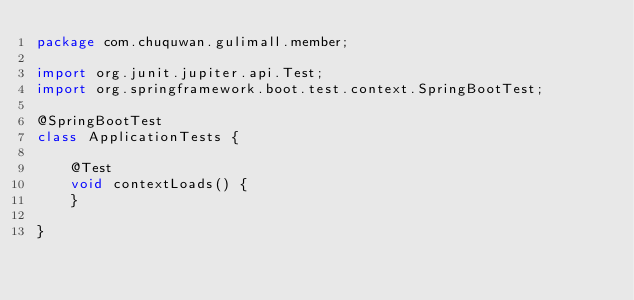Convert code to text. <code><loc_0><loc_0><loc_500><loc_500><_Java_>package com.chuquwan.gulimall.member;

import org.junit.jupiter.api.Test;
import org.springframework.boot.test.context.SpringBootTest;

@SpringBootTest
class ApplicationTests {

    @Test
    void contextLoads() {
    }

}
</code> 